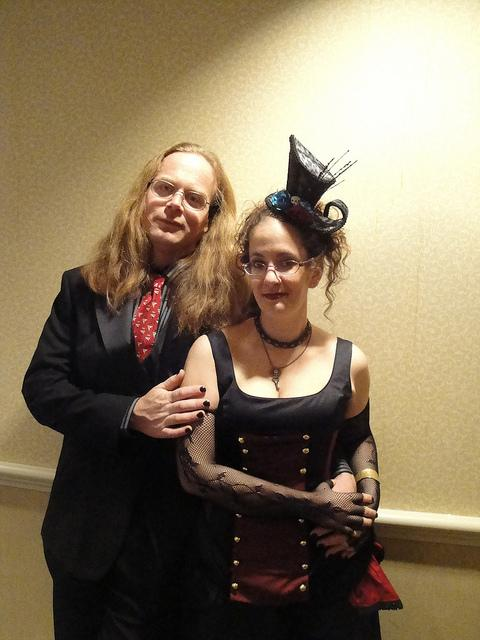Why is the woman wearing a hat? Please explain your reasoning. costume. The man and woman are dressed up for halloween or some similar occasion. 